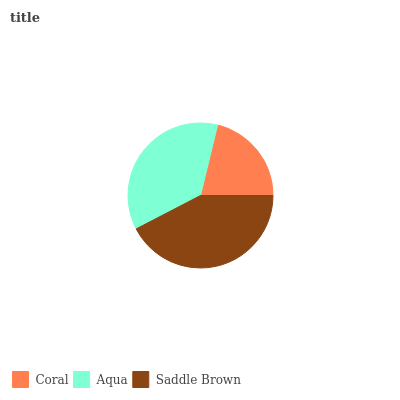Is Coral the minimum?
Answer yes or no. Yes. Is Saddle Brown the maximum?
Answer yes or no. Yes. Is Aqua the minimum?
Answer yes or no. No. Is Aqua the maximum?
Answer yes or no. No. Is Aqua greater than Coral?
Answer yes or no. Yes. Is Coral less than Aqua?
Answer yes or no. Yes. Is Coral greater than Aqua?
Answer yes or no. No. Is Aqua less than Coral?
Answer yes or no. No. Is Aqua the high median?
Answer yes or no. Yes. Is Aqua the low median?
Answer yes or no. Yes. Is Coral the high median?
Answer yes or no. No. Is Saddle Brown the low median?
Answer yes or no. No. 